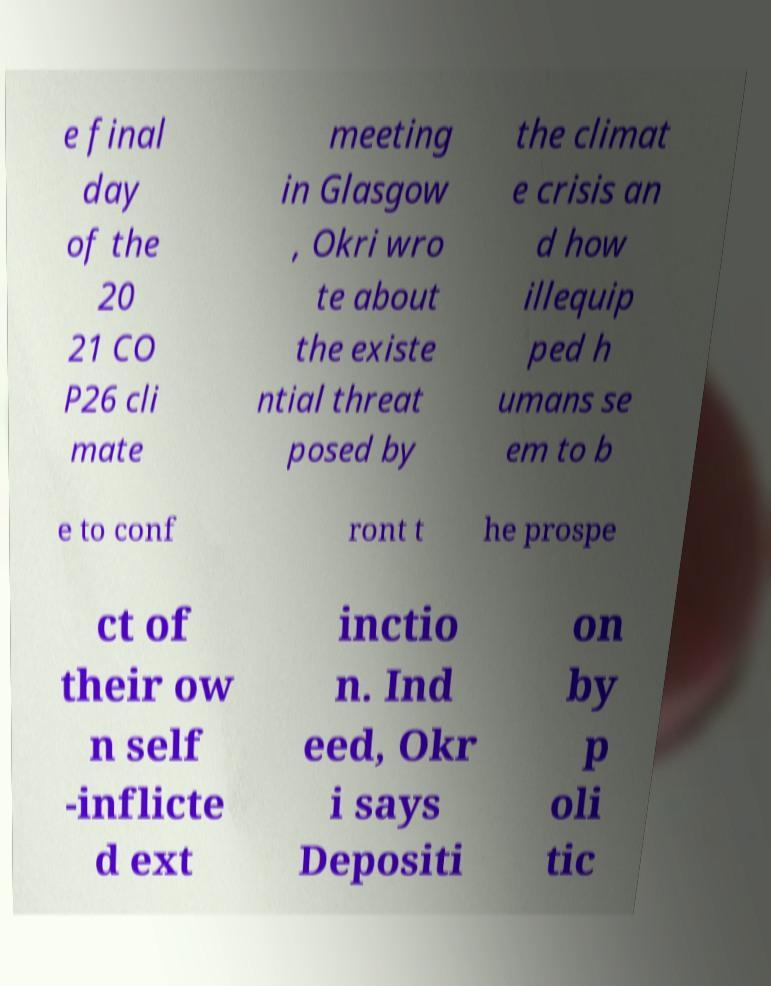Can you read and provide the text displayed in the image?This photo seems to have some interesting text. Can you extract and type it out for me? e final day of the 20 21 CO P26 cli mate meeting in Glasgow , Okri wro te about the existe ntial threat posed by the climat e crisis an d how illequip ped h umans se em to b e to conf ront t he prospe ct of their ow n self -inflicte d ext inctio n. Ind eed, Okr i says Depositi on by p oli tic 